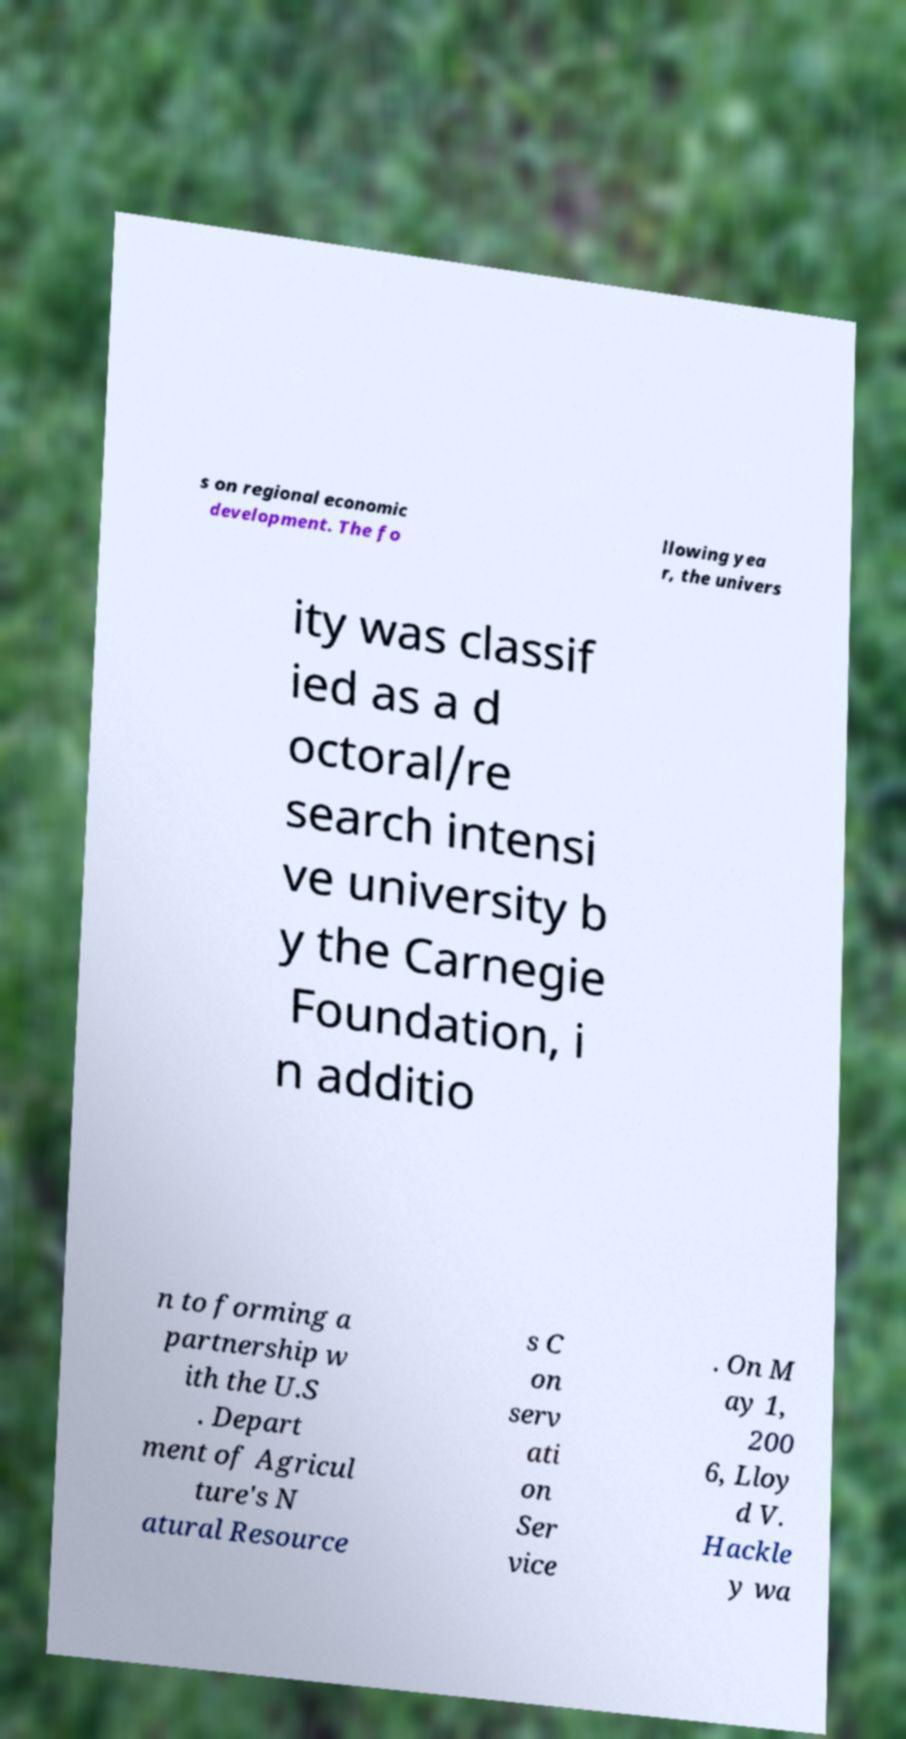Could you assist in decoding the text presented in this image and type it out clearly? s on regional economic development. The fo llowing yea r, the univers ity was classif ied as a d octoral/re search intensi ve university b y the Carnegie Foundation, i n additio n to forming a partnership w ith the U.S . Depart ment of Agricul ture's N atural Resource s C on serv ati on Ser vice . On M ay 1, 200 6, Lloy d V. Hackle y wa 